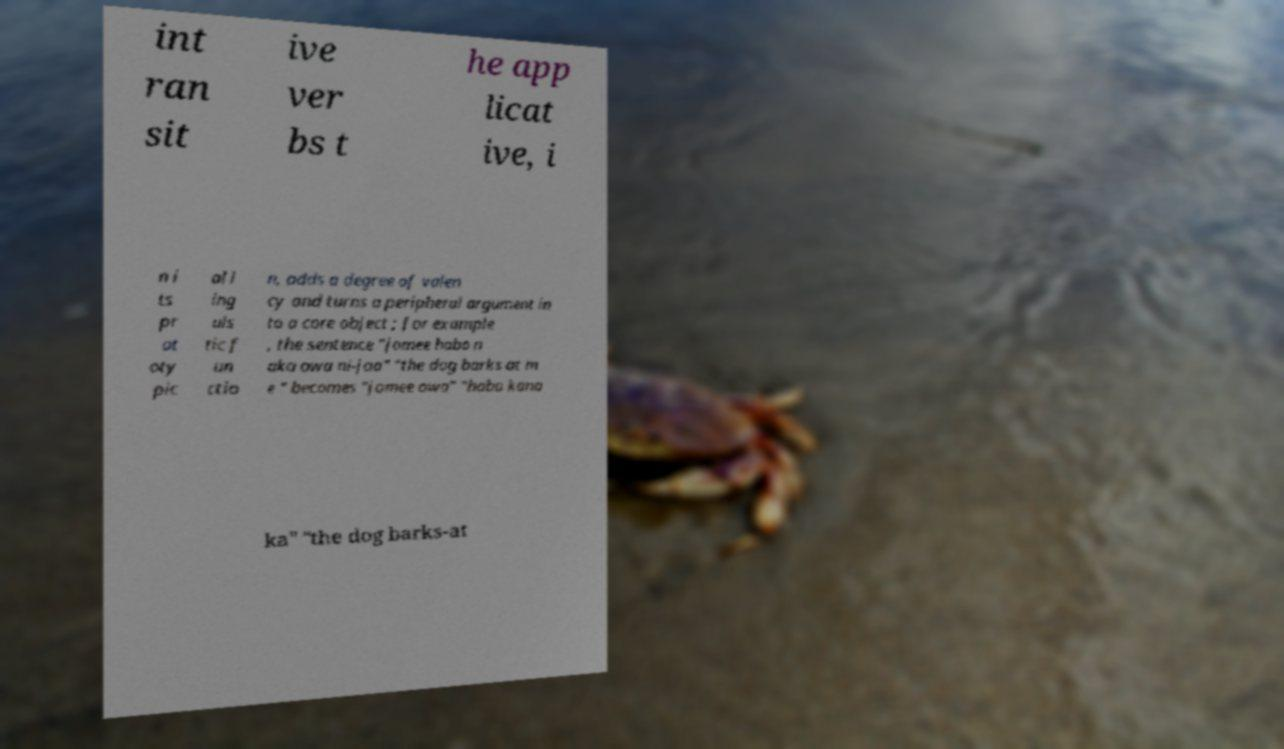Could you assist in decoding the text presented in this image and type it out clearly? int ran sit ive ver bs t he app licat ive, i n i ts pr ot oty pic al l ing uis tic f un ctio n, adds a degree of valen cy and turns a peripheral argument in to a core object ; for example , the sentence "jomee habo n aka owa ni-jaa" "the dog barks at m e " becomes "jomee owa" "habo kana ka" "the dog barks-at 